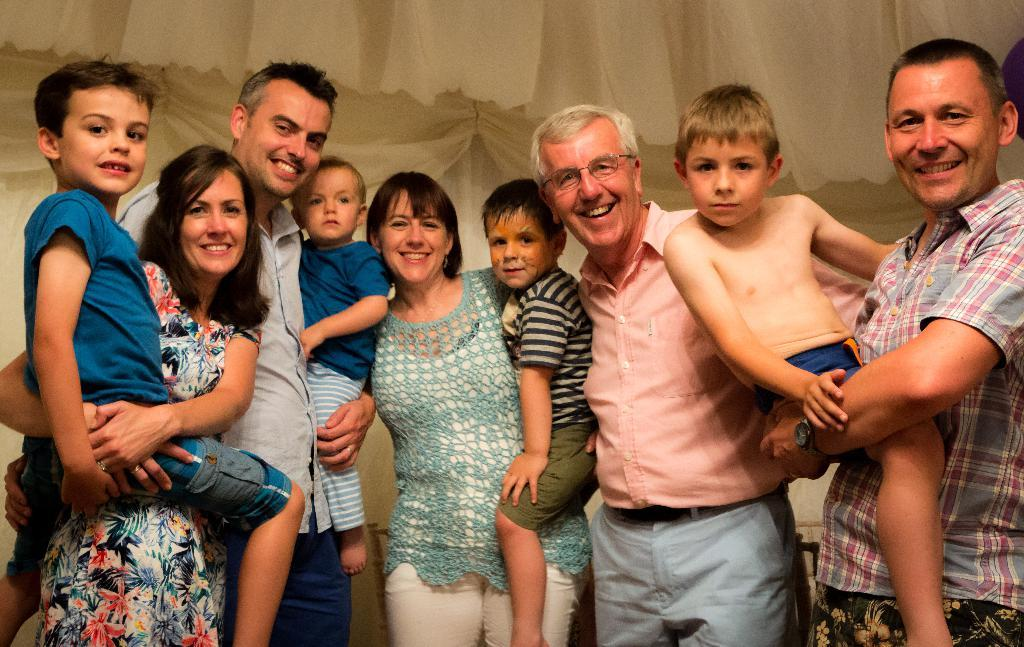What is happening in the image involving a group of people? There is a group of people in the image, and they are standing. How are the people in the image feeling or expressing themselves? The people in the image are smiling. What can be seen in the background of the image? There are curtains in the background of the image. What type of celery is being discussed by the group of people in the image? There is no indication of a discussion about celery or any other food item in the image. 